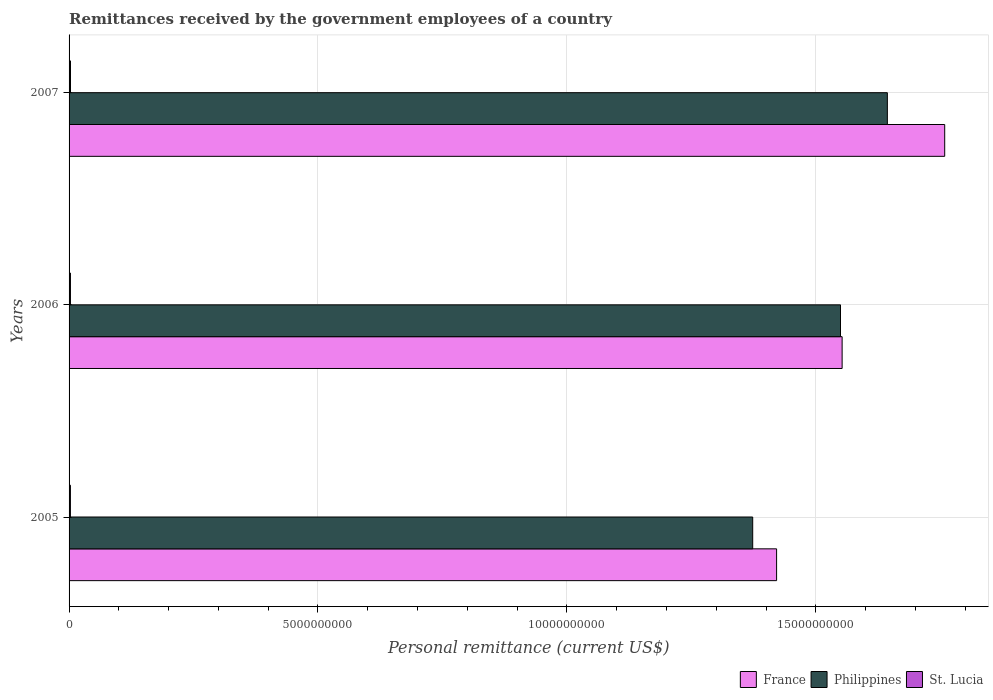What is the label of the 1st group of bars from the top?
Make the answer very short. 2007. What is the remittances received by the government employees in Philippines in 2006?
Your response must be concise. 1.55e+1. Across all years, what is the maximum remittances received by the government employees in Philippines?
Your response must be concise. 1.64e+1. Across all years, what is the minimum remittances received by the government employees in Philippines?
Ensure brevity in your answer.  1.37e+1. In which year was the remittances received by the government employees in Philippines minimum?
Your answer should be very brief. 2005. What is the total remittances received by the government employees in France in the graph?
Your answer should be very brief. 4.73e+1. What is the difference between the remittances received by the government employees in St. Lucia in 2006 and that in 2007?
Your answer should be very brief. -7.69e+05. What is the difference between the remittances received by the government employees in St. Lucia in 2006 and the remittances received by the government employees in France in 2007?
Offer a very short reply. -1.76e+1. What is the average remittances received by the government employees in Philippines per year?
Provide a succinct answer. 1.52e+1. In the year 2006, what is the difference between the remittances received by the government employees in Philippines and remittances received by the government employees in France?
Offer a terse response. -3.28e+07. In how many years, is the remittances received by the government employees in St. Lucia greater than 1000000000 US$?
Provide a succinct answer. 0. What is the ratio of the remittances received by the government employees in France in 2006 to that in 2007?
Your answer should be compact. 0.88. Is the remittances received by the government employees in Philippines in 2005 less than that in 2007?
Your response must be concise. Yes. Is the difference between the remittances received by the government employees in Philippines in 2006 and 2007 greater than the difference between the remittances received by the government employees in France in 2006 and 2007?
Your response must be concise. Yes. What is the difference between the highest and the second highest remittances received by the government employees in St. Lucia?
Give a very brief answer. 7.69e+05. What is the difference between the highest and the lowest remittances received by the government employees in France?
Your answer should be very brief. 3.38e+09. In how many years, is the remittances received by the government employees in France greater than the average remittances received by the government employees in France taken over all years?
Your answer should be very brief. 1. What does the 3rd bar from the top in 2005 represents?
Offer a terse response. France. Is it the case that in every year, the sum of the remittances received by the government employees in St. Lucia and remittances received by the government employees in France is greater than the remittances received by the government employees in Philippines?
Give a very brief answer. Yes. How many years are there in the graph?
Your answer should be very brief. 3. What is the difference between two consecutive major ticks on the X-axis?
Make the answer very short. 5.00e+09. Are the values on the major ticks of X-axis written in scientific E-notation?
Give a very brief answer. No. Does the graph contain grids?
Your response must be concise. Yes. Where does the legend appear in the graph?
Your answer should be compact. Bottom right. How many legend labels are there?
Ensure brevity in your answer.  3. How are the legend labels stacked?
Your answer should be compact. Horizontal. What is the title of the graph?
Ensure brevity in your answer.  Remittances received by the government employees of a country. Does "Honduras" appear as one of the legend labels in the graph?
Offer a terse response. No. What is the label or title of the X-axis?
Provide a succinct answer. Personal remittance (current US$). What is the label or title of the Y-axis?
Provide a succinct answer. Years. What is the Personal remittance (current US$) of France in 2005?
Keep it short and to the point. 1.42e+1. What is the Personal remittance (current US$) of Philippines in 2005?
Provide a short and direct response. 1.37e+1. What is the Personal remittance (current US$) in St. Lucia in 2005?
Your response must be concise. 2.71e+07. What is the Personal remittance (current US$) in France in 2006?
Your response must be concise. 1.55e+1. What is the Personal remittance (current US$) in Philippines in 2006?
Your answer should be very brief. 1.55e+1. What is the Personal remittance (current US$) of St. Lucia in 2006?
Provide a short and direct response. 2.78e+07. What is the Personal remittance (current US$) of France in 2007?
Offer a very short reply. 1.76e+1. What is the Personal remittance (current US$) of Philippines in 2007?
Offer a very short reply. 1.64e+1. What is the Personal remittance (current US$) in St. Lucia in 2007?
Give a very brief answer. 2.86e+07. Across all years, what is the maximum Personal remittance (current US$) in France?
Ensure brevity in your answer.  1.76e+1. Across all years, what is the maximum Personal remittance (current US$) of Philippines?
Offer a terse response. 1.64e+1. Across all years, what is the maximum Personal remittance (current US$) in St. Lucia?
Ensure brevity in your answer.  2.86e+07. Across all years, what is the minimum Personal remittance (current US$) in France?
Offer a very short reply. 1.42e+1. Across all years, what is the minimum Personal remittance (current US$) of Philippines?
Your answer should be very brief. 1.37e+1. Across all years, what is the minimum Personal remittance (current US$) in St. Lucia?
Your answer should be compact. 2.71e+07. What is the total Personal remittance (current US$) of France in the graph?
Make the answer very short. 4.73e+1. What is the total Personal remittance (current US$) in Philippines in the graph?
Offer a terse response. 4.57e+1. What is the total Personal remittance (current US$) in St. Lucia in the graph?
Give a very brief answer. 8.35e+07. What is the difference between the Personal remittance (current US$) in France in 2005 and that in 2006?
Offer a very short reply. -1.32e+09. What is the difference between the Personal remittance (current US$) in Philippines in 2005 and that in 2006?
Your answer should be compact. -1.76e+09. What is the difference between the Personal remittance (current US$) in St. Lucia in 2005 and that in 2006?
Provide a succinct answer. -7.73e+05. What is the difference between the Personal remittance (current US$) in France in 2005 and that in 2007?
Your response must be concise. -3.38e+09. What is the difference between the Personal remittance (current US$) of Philippines in 2005 and that in 2007?
Offer a terse response. -2.70e+09. What is the difference between the Personal remittance (current US$) of St. Lucia in 2005 and that in 2007?
Keep it short and to the point. -1.54e+06. What is the difference between the Personal remittance (current US$) in France in 2006 and that in 2007?
Make the answer very short. -2.06e+09. What is the difference between the Personal remittance (current US$) in Philippines in 2006 and that in 2007?
Make the answer very short. -9.41e+08. What is the difference between the Personal remittance (current US$) in St. Lucia in 2006 and that in 2007?
Keep it short and to the point. -7.69e+05. What is the difference between the Personal remittance (current US$) of France in 2005 and the Personal remittance (current US$) of Philippines in 2006?
Provide a succinct answer. -1.28e+09. What is the difference between the Personal remittance (current US$) of France in 2005 and the Personal remittance (current US$) of St. Lucia in 2006?
Provide a short and direct response. 1.42e+1. What is the difference between the Personal remittance (current US$) in Philippines in 2005 and the Personal remittance (current US$) in St. Lucia in 2006?
Your response must be concise. 1.37e+1. What is the difference between the Personal remittance (current US$) in France in 2005 and the Personal remittance (current US$) in Philippines in 2007?
Offer a terse response. -2.23e+09. What is the difference between the Personal remittance (current US$) in France in 2005 and the Personal remittance (current US$) in St. Lucia in 2007?
Give a very brief answer. 1.42e+1. What is the difference between the Personal remittance (current US$) in Philippines in 2005 and the Personal remittance (current US$) in St. Lucia in 2007?
Your response must be concise. 1.37e+1. What is the difference between the Personal remittance (current US$) in France in 2006 and the Personal remittance (current US$) in Philippines in 2007?
Provide a succinct answer. -9.09e+08. What is the difference between the Personal remittance (current US$) of France in 2006 and the Personal remittance (current US$) of St. Lucia in 2007?
Your response must be concise. 1.55e+1. What is the difference between the Personal remittance (current US$) of Philippines in 2006 and the Personal remittance (current US$) of St. Lucia in 2007?
Provide a succinct answer. 1.55e+1. What is the average Personal remittance (current US$) of France per year?
Provide a succinct answer. 1.58e+1. What is the average Personal remittance (current US$) in Philippines per year?
Offer a very short reply. 1.52e+1. What is the average Personal remittance (current US$) in St. Lucia per year?
Your response must be concise. 2.78e+07. In the year 2005, what is the difference between the Personal remittance (current US$) in France and Personal remittance (current US$) in Philippines?
Provide a short and direct response. 4.80e+08. In the year 2005, what is the difference between the Personal remittance (current US$) of France and Personal remittance (current US$) of St. Lucia?
Provide a succinct answer. 1.42e+1. In the year 2005, what is the difference between the Personal remittance (current US$) in Philippines and Personal remittance (current US$) in St. Lucia?
Provide a succinct answer. 1.37e+1. In the year 2006, what is the difference between the Personal remittance (current US$) in France and Personal remittance (current US$) in Philippines?
Your answer should be very brief. 3.28e+07. In the year 2006, what is the difference between the Personal remittance (current US$) of France and Personal remittance (current US$) of St. Lucia?
Your response must be concise. 1.55e+1. In the year 2006, what is the difference between the Personal remittance (current US$) in Philippines and Personal remittance (current US$) in St. Lucia?
Make the answer very short. 1.55e+1. In the year 2007, what is the difference between the Personal remittance (current US$) of France and Personal remittance (current US$) of Philippines?
Provide a short and direct response. 1.15e+09. In the year 2007, what is the difference between the Personal remittance (current US$) in France and Personal remittance (current US$) in St. Lucia?
Provide a short and direct response. 1.76e+1. In the year 2007, what is the difference between the Personal remittance (current US$) of Philippines and Personal remittance (current US$) of St. Lucia?
Offer a very short reply. 1.64e+1. What is the ratio of the Personal remittance (current US$) in France in 2005 to that in 2006?
Your answer should be compact. 0.92. What is the ratio of the Personal remittance (current US$) in Philippines in 2005 to that in 2006?
Provide a short and direct response. 0.89. What is the ratio of the Personal remittance (current US$) of St. Lucia in 2005 to that in 2006?
Provide a short and direct response. 0.97. What is the ratio of the Personal remittance (current US$) of France in 2005 to that in 2007?
Keep it short and to the point. 0.81. What is the ratio of the Personal remittance (current US$) in Philippines in 2005 to that in 2007?
Give a very brief answer. 0.84. What is the ratio of the Personal remittance (current US$) in St. Lucia in 2005 to that in 2007?
Provide a succinct answer. 0.95. What is the ratio of the Personal remittance (current US$) in France in 2006 to that in 2007?
Give a very brief answer. 0.88. What is the ratio of the Personal remittance (current US$) of Philippines in 2006 to that in 2007?
Provide a short and direct response. 0.94. What is the ratio of the Personal remittance (current US$) of St. Lucia in 2006 to that in 2007?
Give a very brief answer. 0.97. What is the difference between the highest and the second highest Personal remittance (current US$) in France?
Ensure brevity in your answer.  2.06e+09. What is the difference between the highest and the second highest Personal remittance (current US$) of Philippines?
Your response must be concise. 9.41e+08. What is the difference between the highest and the second highest Personal remittance (current US$) in St. Lucia?
Offer a very short reply. 7.69e+05. What is the difference between the highest and the lowest Personal remittance (current US$) in France?
Give a very brief answer. 3.38e+09. What is the difference between the highest and the lowest Personal remittance (current US$) in Philippines?
Your response must be concise. 2.70e+09. What is the difference between the highest and the lowest Personal remittance (current US$) in St. Lucia?
Your response must be concise. 1.54e+06. 